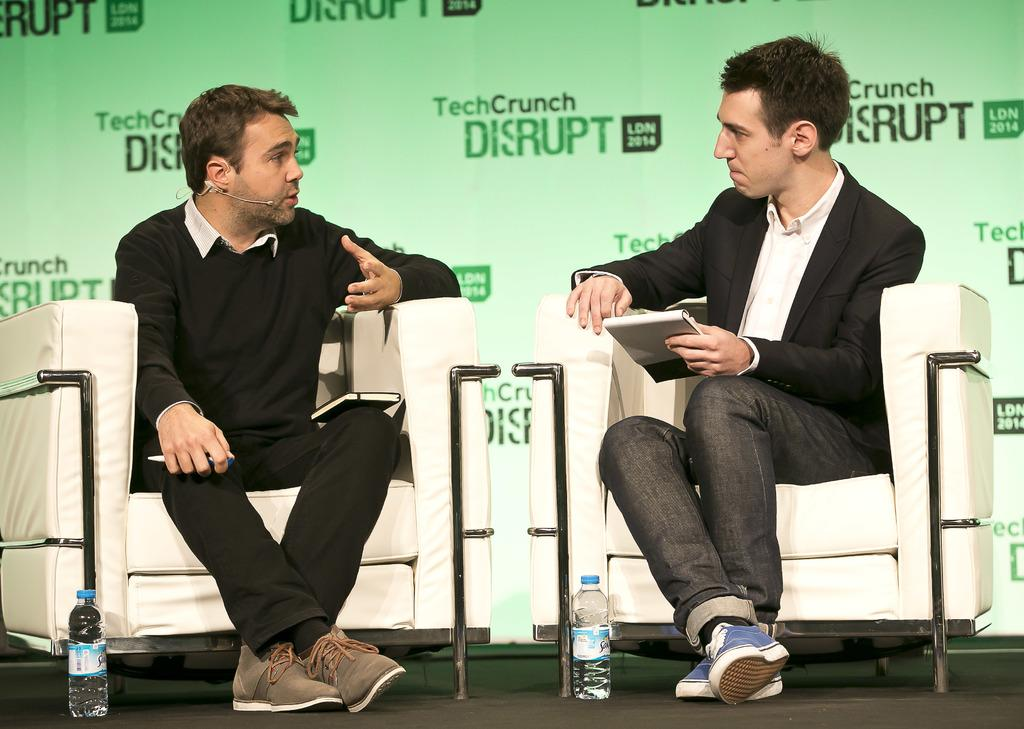How many people are in the image? There are persons in the image, but the exact number is not specified. What can be seen besides the persons in the image? There are bottles, books, chairs, a pen, and other objects in the image. What is hanging in the background of the image? There is a banner in the background of the image. What is visible at the bottom of the image? The floor is visible at the bottom of the image. How many rabbits are performing magic tricks in the image? There are no rabbits or magic tricks present in the image. 